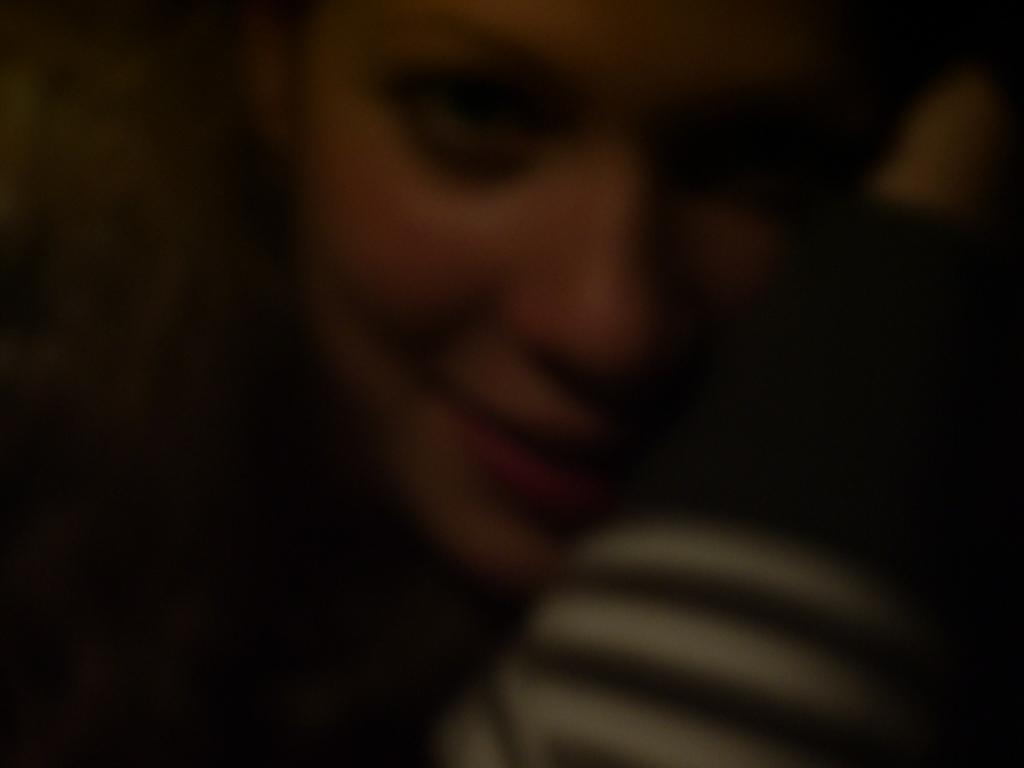Can you describe this image briefly? In this image, we can see a person smiling. 